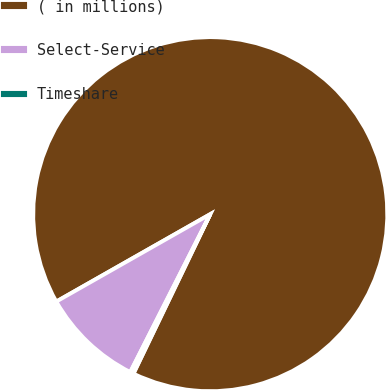Convert chart to OTSL. <chart><loc_0><loc_0><loc_500><loc_500><pie_chart><fcel>( in millions)<fcel>Select-Service<fcel>Timeshare<nl><fcel>90.36%<fcel>9.32%<fcel>0.32%<nl></chart> 